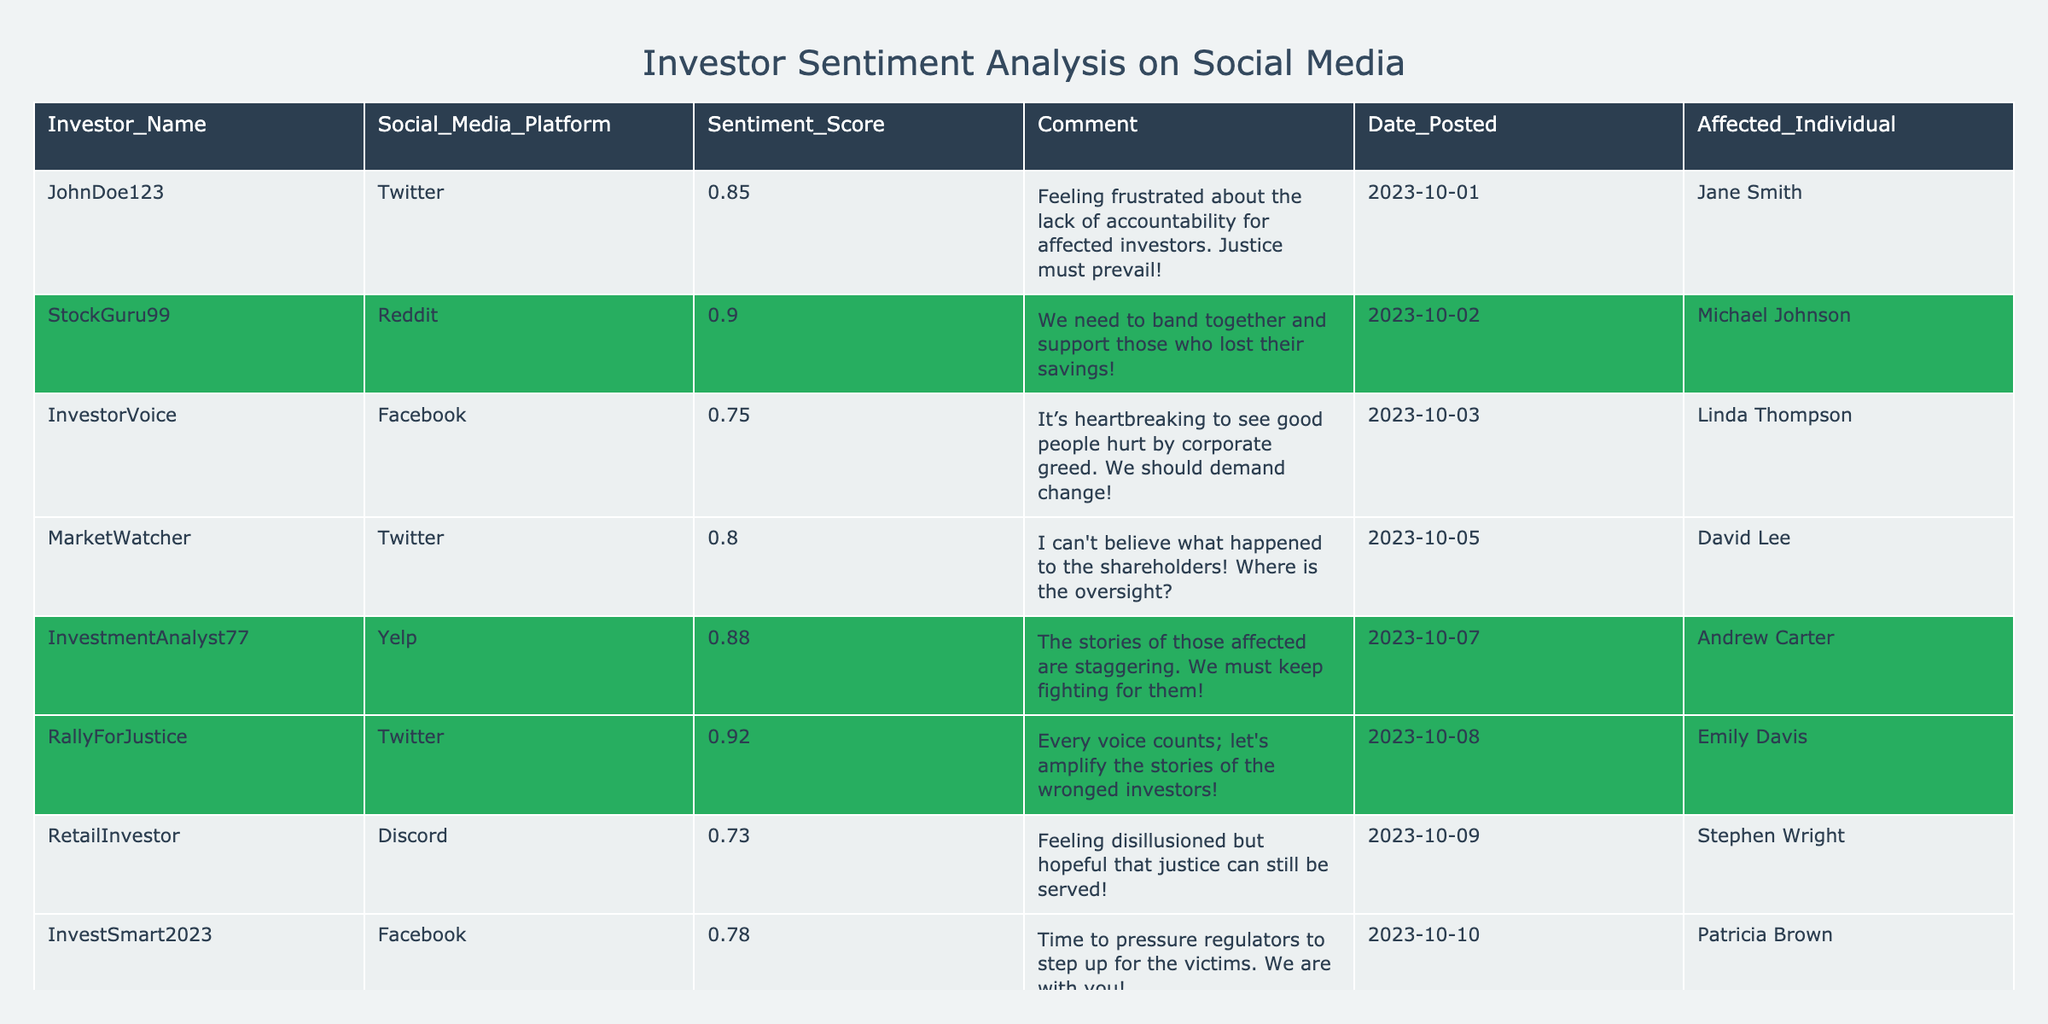What is the sentiment score of JohnDoe123 on Twitter? The sentiment score for JohnDoe123 is given directly in the table, which shows a score of 0.85.
Answer: 0.85 Which affected individual has the highest sentiment score related to their case? By reviewing the sentiment scores in the table, the highest score is 0.92, associated with Emily Davis.
Answer: Emily Davis Is there any investor who expressed a sentiment score below 0.75? By checking the sentiment scores listed, RetailInvestor has a score of 0.73, which is indeed below 0.75.
Answer: Yes What is the average sentiment score of all investors listed in the table? The sentiment scores are 0.85, 0.90, 0.75, 0.80, 0.88, 0.92, 0.73, 0.78, and 0.86. Summing these gives 7.16, and dividing by the number of investors (9) gives an average of approximately 0.795.
Answer: 0.795 Which social media platform had the highest average sentiment score? First, we need to group the sentiment scores by platform: Twitter has (0.85 + 0.80 + 0.92) = 2.57 over 3 posts, giving an average of 0.857. Reddit has (0.90 + 0.86) = 1.76 over 2 posts, giving an average of 0.88. Facebook has (0.75 + 0.78) = 1.53 over 2 posts, giving an average of 0.765. Yelp has 0.88, and Discord has 0.73. The highest average is 0.88 from Reddit.
Answer: Reddit How many different individuals were affected according to the table? By counting the unique names listed under the "Affected_Individual" column, we find that there are 7 unique individuals: Jane Smith, Michael Johnson, Linda Thompson, David Lee, Andrew Carter, Emily Davis, Stephen Wright, and Patricia Brown, totaling 8.
Answer: 8 Is there a post that mentions the need for regulatory pressure? The sentiment score of 0.78 from InvestSmart2023 on Facebook contains the comment about pressing regulators to step up for the victims. Therefore, yes, there is such a post.
Answer: Yes Which individual had the earliest post date, and what was the sentiment score for that post? The earliest date in the table is 2023-10-01 from JohnDoe123, with a sentiment score of 0.85.
Answer: JohnDoe123, 0.85 What sentiment score is associated with MarketWatcher’s comments about oversight? The table shows that MarketWatcher has a sentiment score of 0.80.
Answer: 0.80 Is there any comment expressing a sense of hope regarding justice? RetailInvestor's comment regarding feeling disillusioned but hopeful reflects a sense of hope, and they have a sentiment score of 0.73.
Answer: Yes 